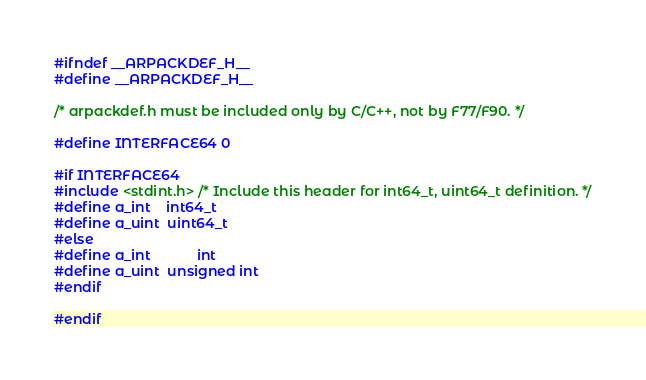<code> <loc_0><loc_0><loc_500><loc_500><_C_>#ifndef __ARPACKDEF_H__
#define __ARPACKDEF_H__

/* arpackdef.h must be included only by C/C++, not by F77/F90. */

#define INTERFACE64 0

#if INTERFACE64
#include <stdint.h> /* Include this header for int64_t, uint64_t definition. */
#define a_int    int64_t
#define a_uint  uint64_t
#else
#define a_int            int
#define a_uint  unsigned int
#endif

#endif
</code> 